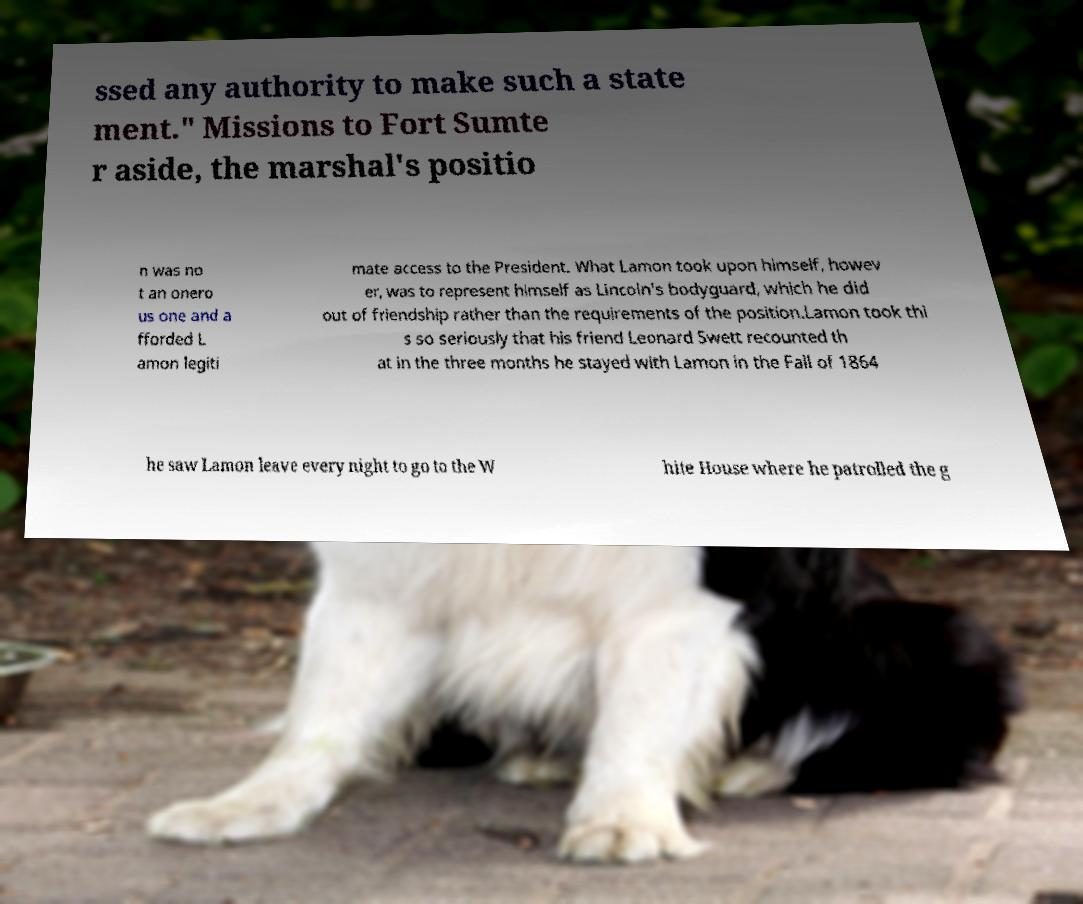There's text embedded in this image that I need extracted. Can you transcribe it verbatim? ssed any authority to make such a state ment." Missions to Fort Sumte r aside, the marshal's positio n was no t an onero us one and a fforded L amon legiti mate access to the President. What Lamon took upon himself, howev er, was to represent himself as Lincoln's bodyguard, which he did out of friendship rather than the requirements of the position.Lamon took thi s so seriously that his friend Leonard Swett recounted th at in the three months he stayed with Lamon in the Fall of 1864 he saw Lamon leave every night to go to the W hite House where he patrolled the g 